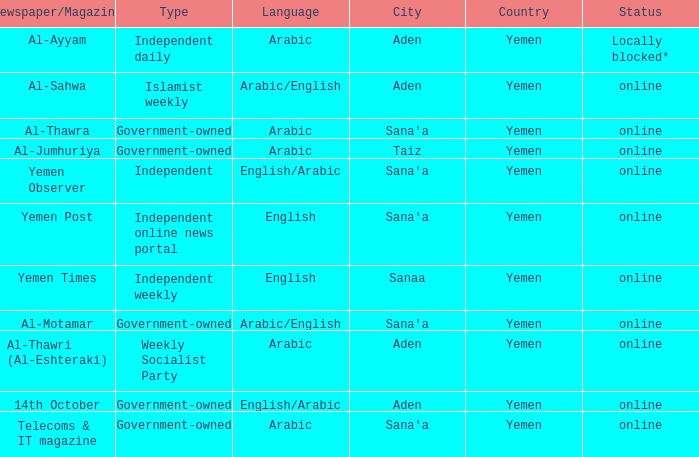What is Status, when Newspaper/Magazine is Al-Thawra? Online. 